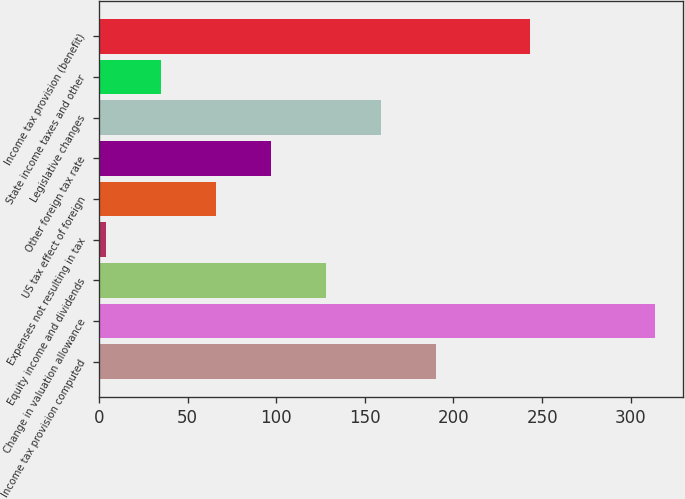<chart> <loc_0><loc_0><loc_500><loc_500><bar_chart><fcel>Income tax provision computed<fcel>Change in valuation allowance<fcel>Equity income and dividends<fcel>Expenses not resulting in tax<fcel>US tax effect of foreign<fcel>Other foreign tax rate<fcel>Legislative changes<fcel>State income taxes and other<fcel>Income tax provision (benefit)<nl><fcel>190<fcel>314<fcel>128<fcel>4<fcel>66<fcel>97<fcel>159<fcel>35<fcel>243<nl></chart> 